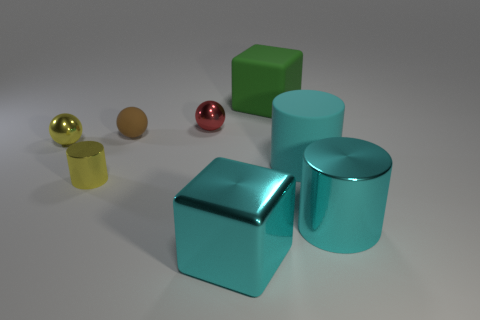Subtract all rubber balls. How many balls are left? 2 Add 2 big cylinders. How many objects exist? 10 Subtract all green blocks. How many cyan cylinders are left? 2 Subtract all green cubes. How many cubes are left? 1 Subtract all cubes. How many objects are left? 6 Add 5 big cyan blocks. How many big cyan blocks are left? 6 Add 2 red matte cylinders. How many red matte cylinders exist? 2 Subtract 0 red blocks. How many objects are left? 8 Subtract all gray spheres. Subtract all gray cubes. How many spheres are left? 3 Subtract all metallic spheres. Subtract all cyan shiny things. How many objects are left? 4 